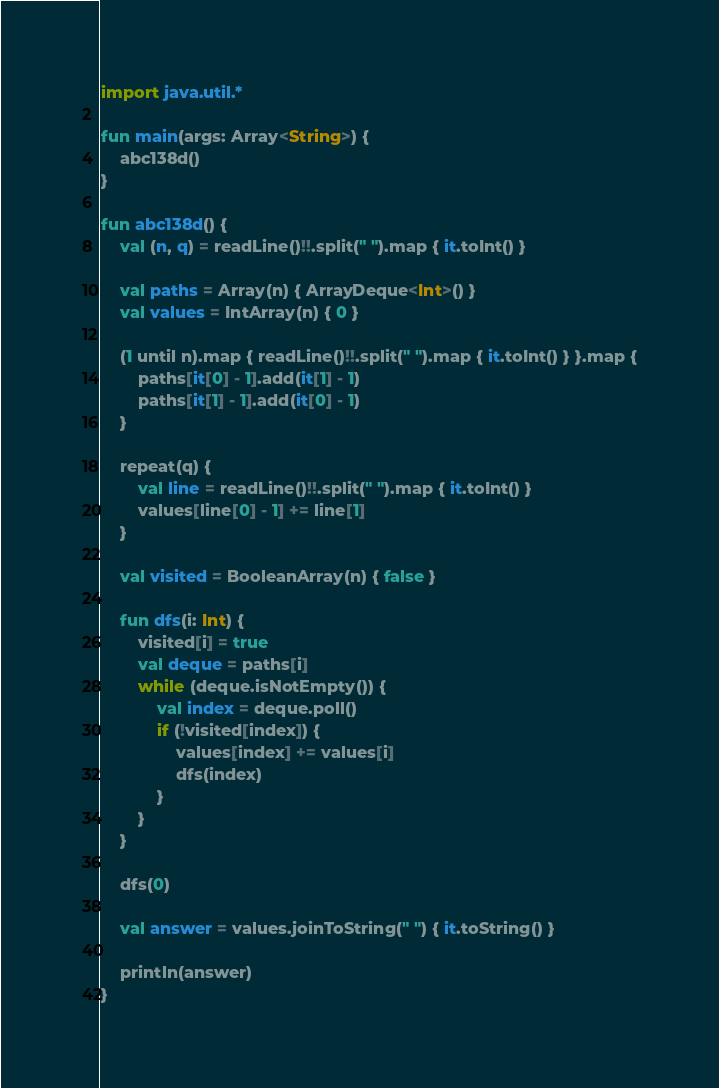<code> <loc_0><loc_0><loc_500><loc_500><_Kotlin_>import java.util.*

fun main(args: Array<String>) {
    abc138d()
}

fun abc138d() {
    val (n, q) = readLine()!!.split(" ").map { it.toInt() }

    val paths = Array(n) { ArrayDeque<Int>() }
    val values = IntArray(n) { 0 }

    (1 until n).map { readLine()!!.split(" ").map { it.toInt() } }.map {
        paths[it[0] - 1].add(it[1] - 1)
        paths[it[1] - 1].add(it[0] - 1)
    }

    repeat(q) {
        val line = readLine()!!.split(" ").map { it.toInt() }
        values[line[0] - 1] += line[1]
    }

    val visited = BooleanArray(n) { false }

    fun dfs(i: Int) {
        visited[i] = true
        val deque = paths[i]
        while (deque.isNotEmpty()) {
            val index = deque.poll()
            if (!visited[index]) {
                values[index] += values[i]
                dfs(index)
            }
        }
    }

    dfs(0)

    val answer = values.joinToString(" ") { it.toString() }

    println(answer)
}
</code> 